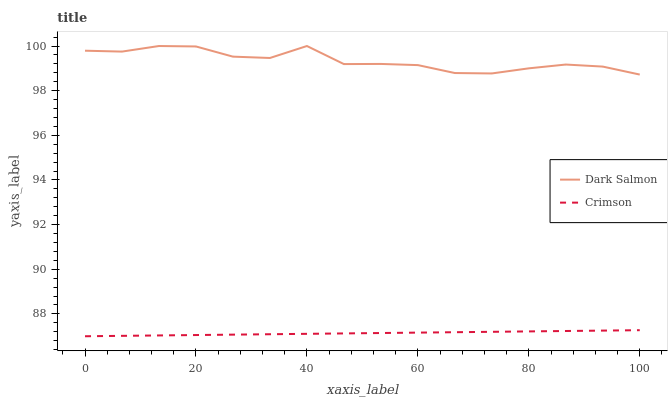Does Crimson have the minimum area under the curve?
Answer yes or no. Yes. Does Dark Salmon have the maximum area under the curve?
Answer yes or no. Yes. Does Dark Salmon have the minimum area under the curve?
Answer yes or no. No. Is Crimson the smoothest?
Answer yes or no. Yes. Is Dark Salmon the roughest?
Answer yes or no. Yes. Is Dark Salmon the smoothest?
Answer yes or no. No. Does Crimson have the lowest value?
Answer yes or no. Yes. Does Dark Salmon have the lowest value?
Answer yes or no. No. Does Dark Salmon have the highest value?
Answer yes or no. Yes. Is Crimson less than Dark Salmon?
Answer yes or no. Yes. Is Dark Salmon greater than Crimson?
Answer yes or no. Yes. Does Crimson intersect Dark Salmon?
Answer yes or no. No. 